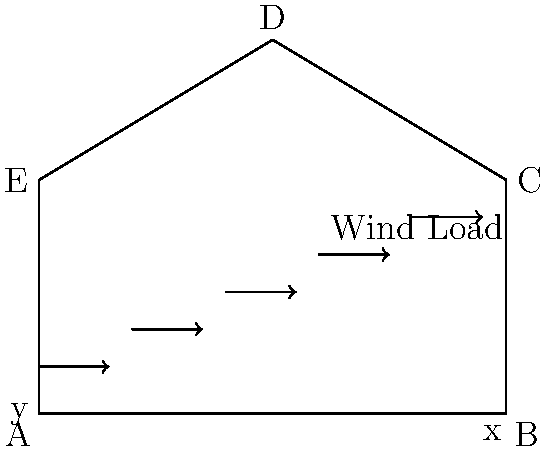As a startup founder developing genetically modified crops, you're designing a greenhouse to optimize growing conditions. The structure shown above represents a cross-section of your greenhouse. Given that the wind load is applied horizontally as indicated, which structural element is likely to experience the highest tensile stress? To determine which structural element experiences the highest tensile stress, we need to analyze the force distribution in the greenhouse structure under wind load:

1. Wind load applies a horizontal force from left to right.

2. This force creates a moment about the base of the structure.

3. The moment tends to rotate the structure clockwise.

4. To resist this rotation:
   a) The left side (AE) will be in tension.
   b) The right side (BC) will be in compression.

5. The roof elements (ED and DC) will experience a combination of bending and axial forces.

6. Among the vertical elements, AE will experience the highest tensile stress because:
   a) It's on the windward side, directly opposing the wind force.
   b) It's resisting the overturning moment created by the wind load.

7. The horizontal element AB may experience some tensile stress, but it's primarily designed to resist compression from the weight of the structure.

8. The diagonal roof elements (ED and DC) will experience mixed stresses, but the tensile component will be less than AE due to their angled orientation.

Therefore, the structural element likely to experience the highest tensile stress is the left vertical member, AE.
Answer: AE (left vertical member) 